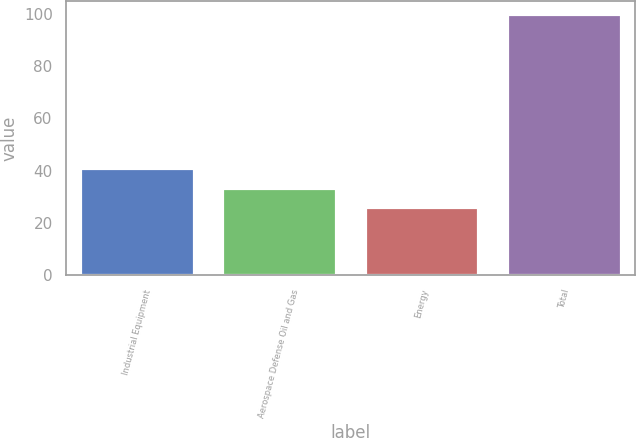Convert chart to OTSL. <chart><loc_0><loc_0><loc_500><loc_500><bar_chart><fcel>Industrial Equipment<fcel>Aerospace Defense Oil and Gas<fcel>Energy<fcel>Total<nl><fcel>41<fcel>33.4<fcel>26<fcel>100<nl></chart> 